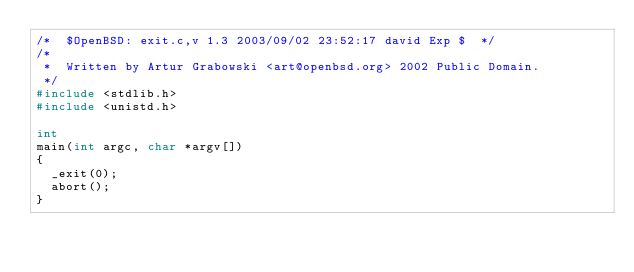<code> <loc_0><loc_0><loc_500><loc_500><_C_>/*	$OpenBSD: exit.c,v 1.3 2003/09/02 23:52:17 david Exp $	*/
/*
 *	Written by Artur Grabowski <art@openbsd.org> 2002 Public Domain.
 */
#include <stdlib.h>
#include <unistd.h>

int
main(int argc, char *argv[])
{	
	_exit(0);
	abort();
}
</code> 